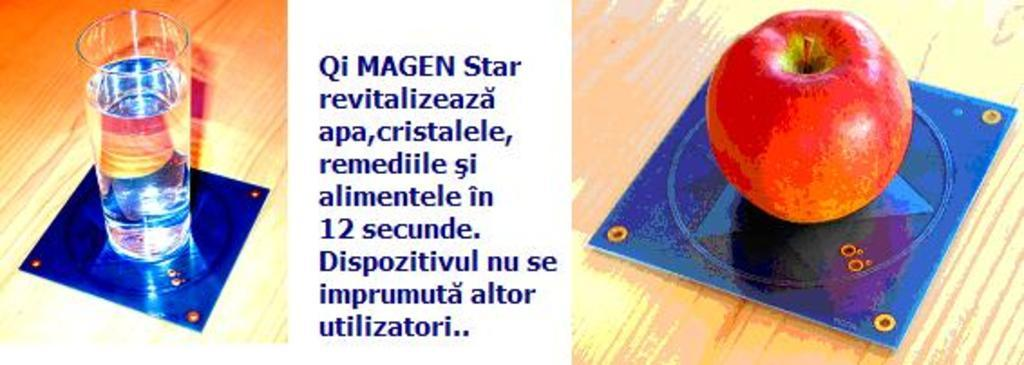What is placed on the table in the image? There is a glass of water, some information (likely text or documents), and an apple on the table. What might be the purpose of the glass of water on the table? The glass of water on the table might be for drinking or for use in the activity related to the information on the table. What type of fruit is present on the table? There is an apple on the table. How many beds are visible in the image? There are no beds visible in the image; it features a table with a glass of water, some information, and an apple. What type of assistance can be provided by the apple in the image? The apple in the image is a fruit and cannot provide any assistance or help. 